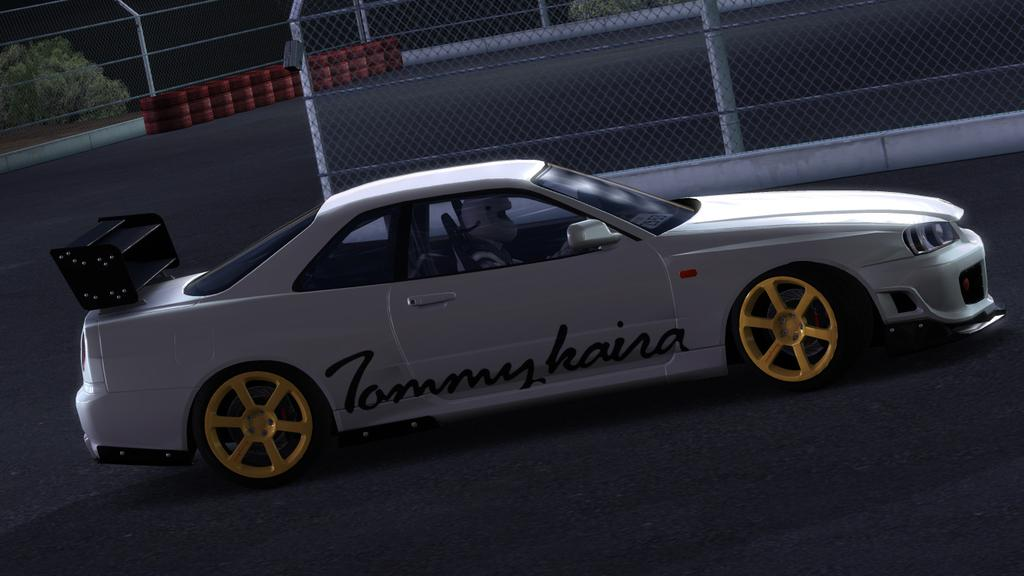What is the main subject of the image? The main subject of the image is a car. Where is the car located in the image? The car is on the road in the image. What can be seen in the background of the image? There is a mesh and trees visible in the background of the image. What is placed behind the mesh in the image? Objects are placed in a side of the road, behind the mesh. What type of crown is being worn by the car in the image? There is no crown present in the image; it features a car on the road with a background of a mesh and trees. 